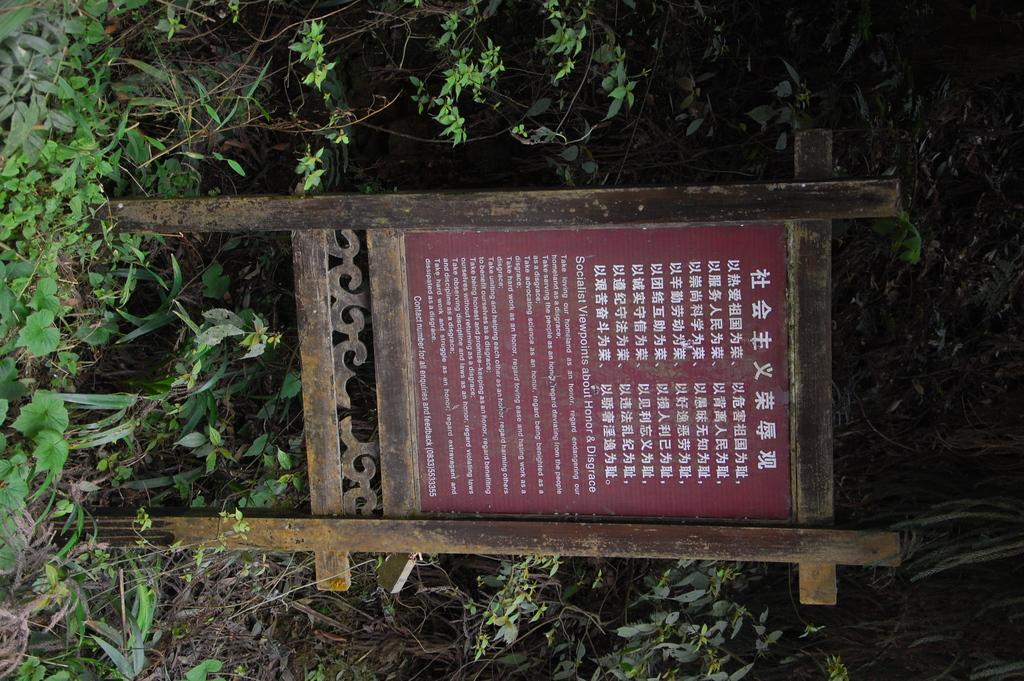What is the main object in the image? There is a board in the image. What other objects can be seen in the image? There are wooden poles in the image. What type of vegetation is present in the image? There are plants in the image, which include leaves and stems. What type of bell can be heard ringing in the image? There is no bell present in the image, and therefore no sound can be heard. 